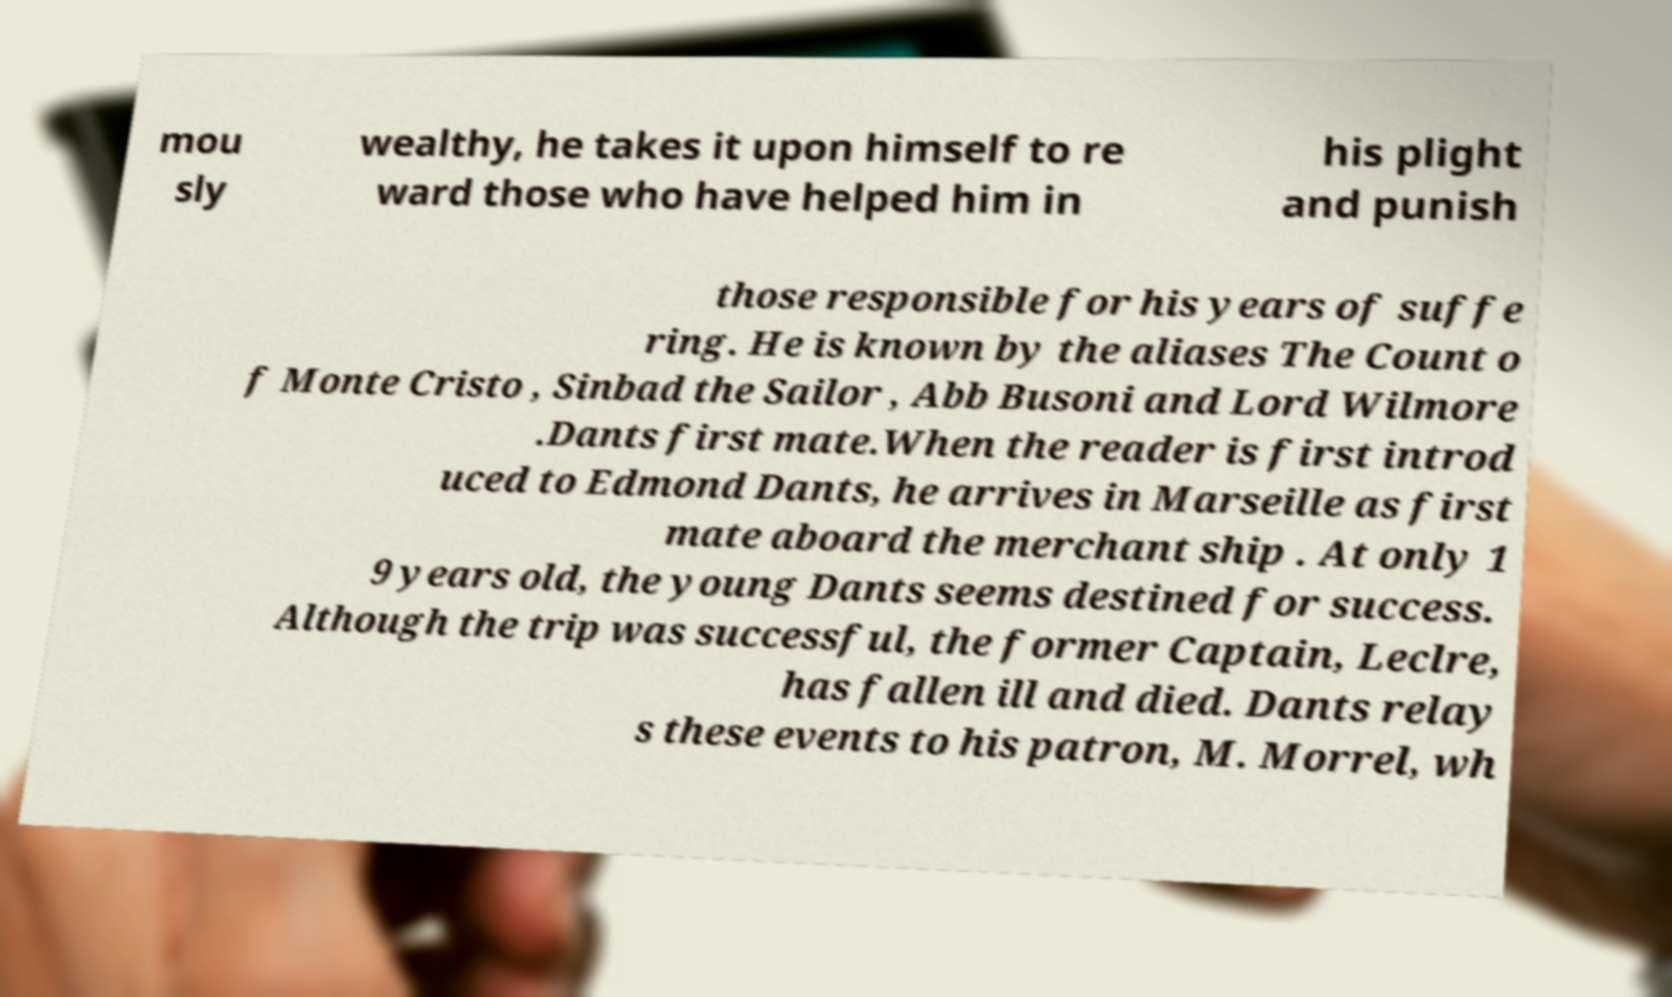What messages or text are displayed in this image? I need them in a readable, typed format. mou sly wealthy, he takes it upon himself to re ward those who have helped him in his plight and punish those responsible for his years of suffe ring. He is known by the aliases The Count o f Monte Cristo , Sinbad the Sailor , Abb Busoni and Lord Wilmore .Dants first mate.When the reader is first introd uced to Edmond Dants, he arrives in Marseille as first mate aboard the merchant ship . At only 1 9 years old, the young Dants seems destined for success. Although the trip was successful, the former Captain, Leclre, has fallen ill and died. Dants relay s these events to his patron, M. Morrel, wh 